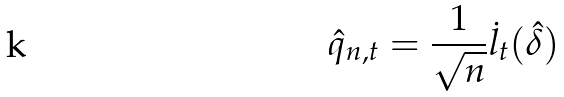Convert formula to latex. <formula><loc_0><loc_0><loc_500><loc_500>\hat { q } _ { n , t } = \frac { 1 } { \sqrt { n } } \dot { l } _ { t } ( \hat { \delta } )</formula> 